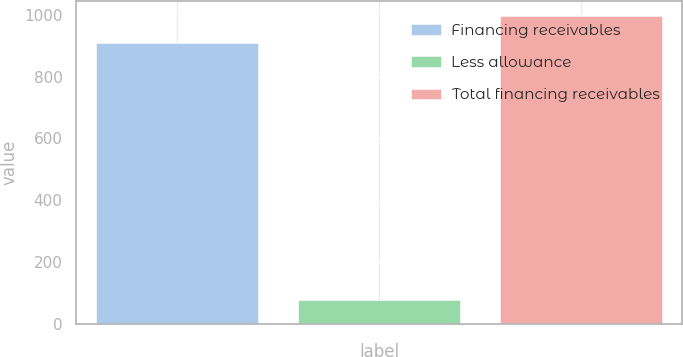Convert chart. <chart><loc_0><loc_0><loc_500><loc_500><bar_chart><fcel>Financing receivables<fcel>Less allowance<fcel>Total financing receivables<nl><fcel>908<fcel>79<fcel>995.1<nl></chart> 